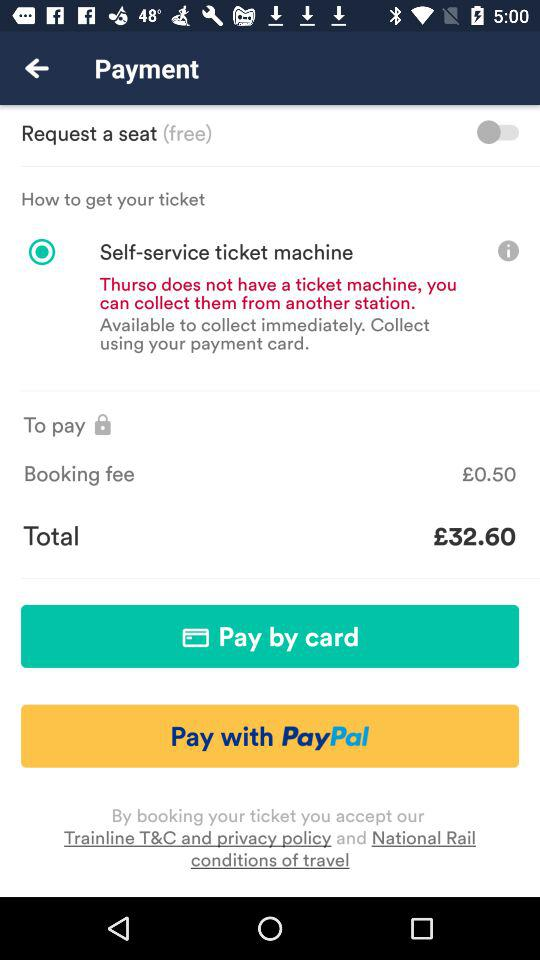What is the status of "Request a seat"? The status is off. 